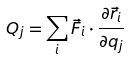Convert formula to latex. <formula><loc_0><loc_0><loc_500><loc_500>Q _ { j } = \sum _ { i } \vec { F } _ { i } \cdot \frac { \partial \vec { r } _ { i } } { \partial q _ { j } }</formula> 